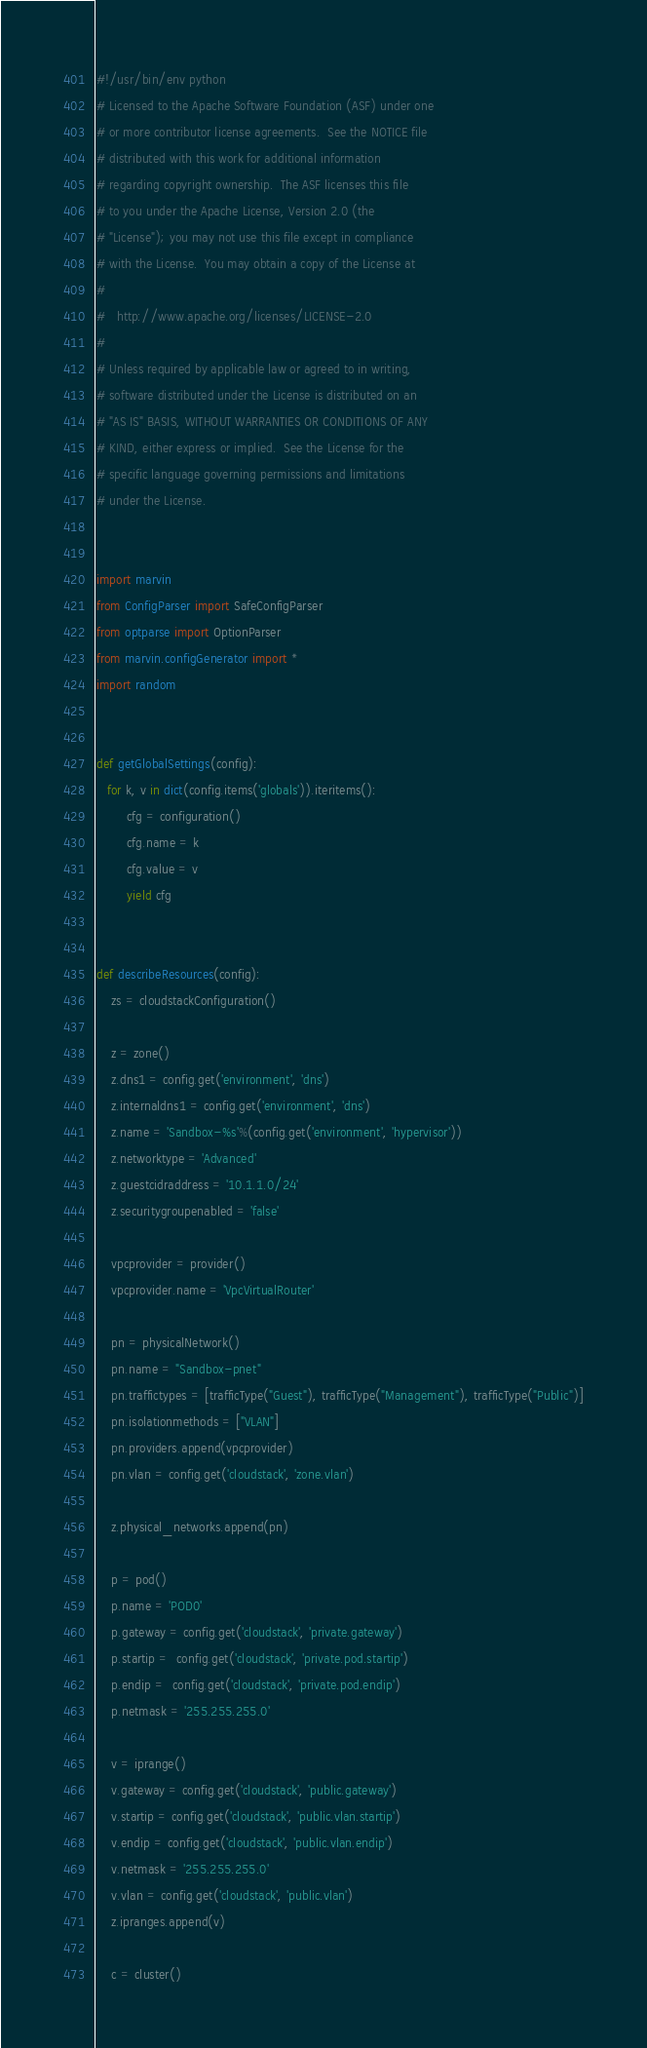<code> <loc_0><loc_0><loc_500><loc_500><_Python_>#!/usr/bin/env python
# Licensed to the Apache Software Foundation (ASF) under one
# or more contributor license agreements.  See the NOTICE file
# distributed with this work for additional information
# regarding copyright ownership.  The ASF licenses this file
# to you under the Apache License, Version 2.0 (the
# "License"); you may not use this file except in compliance
# with the License.  You may obtain a copy of the License at
# 
#   http://www.apache.org/licenses/LICENSE-2.0
# 
# Unless required by applicable law or agreed to in writing,
# software distributed under the License is distributed on an
# "AS IS" BASIS, WITHOUT WARRANTIES OR CONDITIONS OF ANY
# KIND, either express or implied.  See the License for the
# specific language governing permissions and limitations
# under the License.


import marvin
from ConfigParser import SafeConfigParser
from optparse import OptionParser
from marvin.configGenerator import *
import random


def getGlobalSettings(config):
   for k, v in dict(config.items('globals')).iteritems():
        cfg = configuration()
        cfg.name = k
        cfg.value = v
        yield cfg


def describeResources(config):
    zs = cloudstackConfiguration()

    z = zone()
    z.dns1 = config.get('environment', 'dns')
    z.internaldns1 = config.get('environment', 'dns')
    z.name = 'Sandbox-%s'%(config.get('environment', 'hypervisor'))
    z.networktype = 'Advanced'
    z.guestcidraddress = '10.1.1.0/24'
    z.securitygroupenabled = 'false'
    
    vpcprovider = provider()
    vpcprovider.name = 'VpcVirtualRouter'
    
    pn = physicalNetwork()
    pn.name = "Sandbox-pnet"
    pn.traffictypes = [trafficType("Guest"), trafficType("Management"), trafficType("Public")]
    pn.isolationmethods = ["VLAN"]
    pn.providers.append(vpcprovider)
    pn.vlan = config.get('cloudstack', 'zone.vlan')
    
    z.physical_networks.append(pn)

    p = pod()
    p.name = 'POD0'
    p.gateway = config.get('cloudstack', 'private.gateway')
    p.startip =  config.get('cloudstack', 'private.pod.startip')
    p.endip =  config.get('cloudstack', 'private.pod.endip')
    p.netmask = '255.255.255.0'

    v = iprange()
    v.gateway = config.get('cloudstack', 'public.gateway')
    v.startip = config.get('cloudstack', 'public.vlan.startip')
    v.endip = config.get('cloudstack', 'public.vlan.endip') 
    v.netmask = '255.255.255.0'
    v.vlan = config.get('cloudstack', 'public.vlan')
    z.ipranges.append(v)

    c = cluster()</code> 